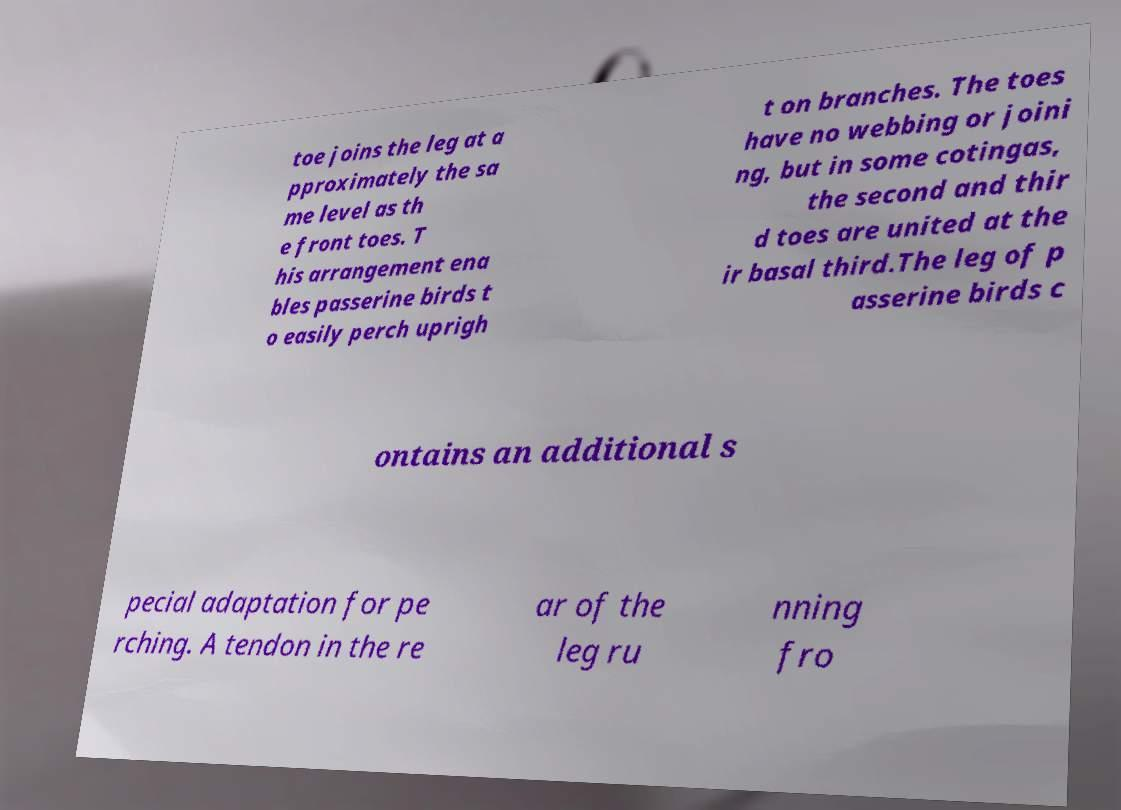There's text embedded in this image that I need extracted. Can you transcribe it verbatim? toe joins the leg at a pproximately the sa me level as th e front toes. T his arrangement ena bles passerine birds t o easily perch uprigh t on branches. The toes have no webbing or joini ng, but in some cotingas, the second and thir d toes are united at the ir basal third.The leg of p asserine birds c ontains an additional s pecial adaptation for pe rching. A tendon in the re ar of the leg ru nning fro 